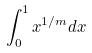Convert formula to latex. <formula><loc_0><loc_0><loc_500><loc_500>\int _ { 0 } ^ { 1 } x ^ { 1 / m } d x</formula> 